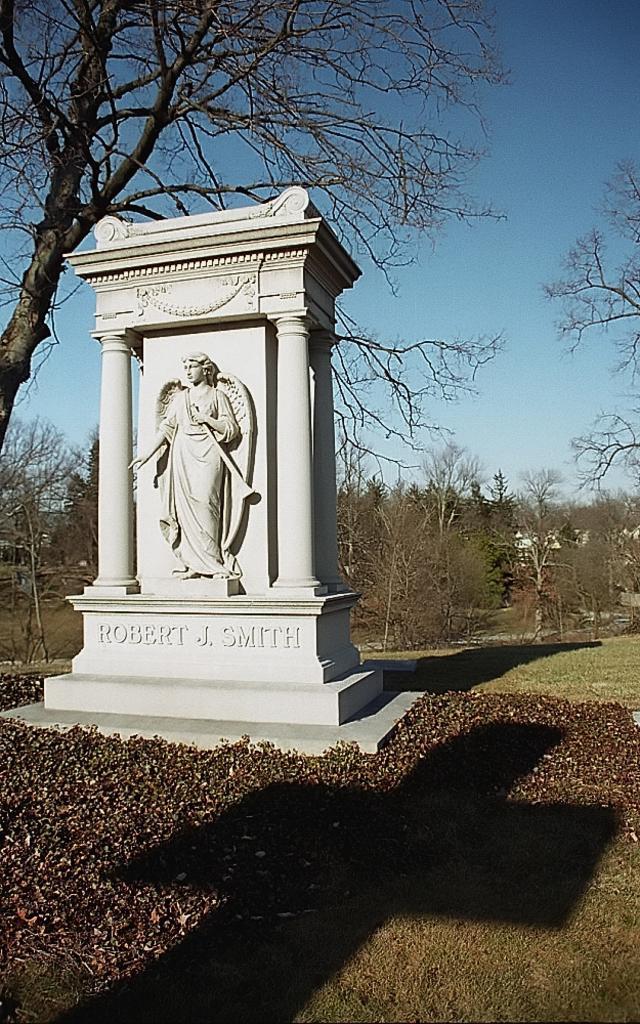Can you describe this image briefly? In this image there is a sculpture to a wall. Below the sculpture there is text on the wall. Around the sculpture there are small plants. To the right there's grass on the ground. In the background there are trees. At the top there is the sky. 